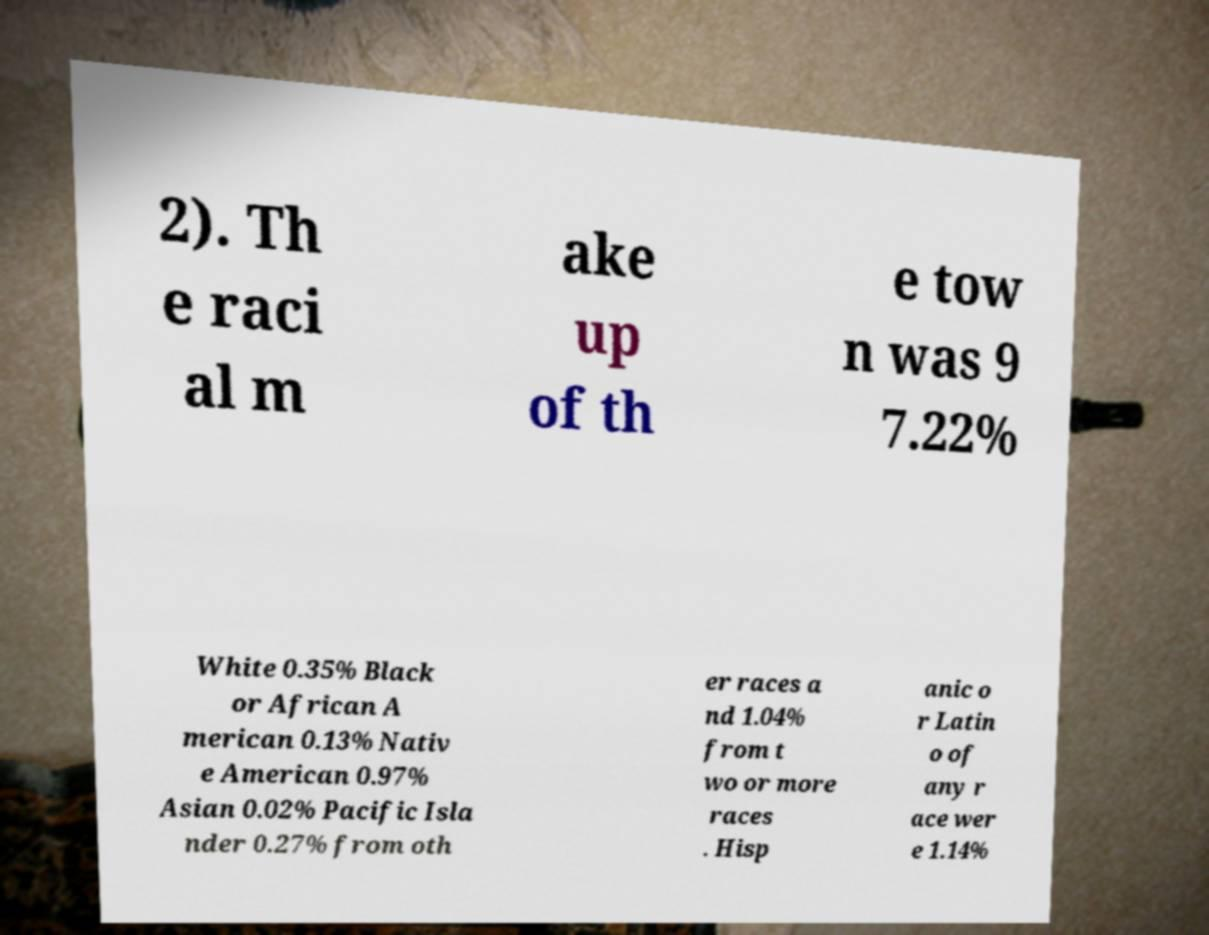Can you accurately transcribe the text from the provided image for me? 2). Th e raci al m ake up of th e tow n was 9 7.22% White 0.35% Black or African A merican 0.13% Nativ e American 0.97% Asian 0.02% Pacific Isla nder 0.27% from oth er races a nd 1.04% from t wo or more races . Hisp anic o r Latin o of any r ace wer e 1.14% 